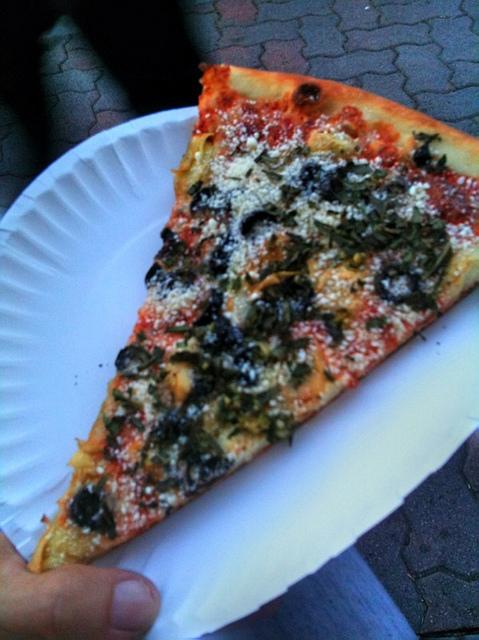What kind of pizza is this?
Be succinct. Spinach. Is this a vegetable pizza?
Answer briefly. Yes. What has been sprinkled over the pizza?
Quick response, please. Cheese. 